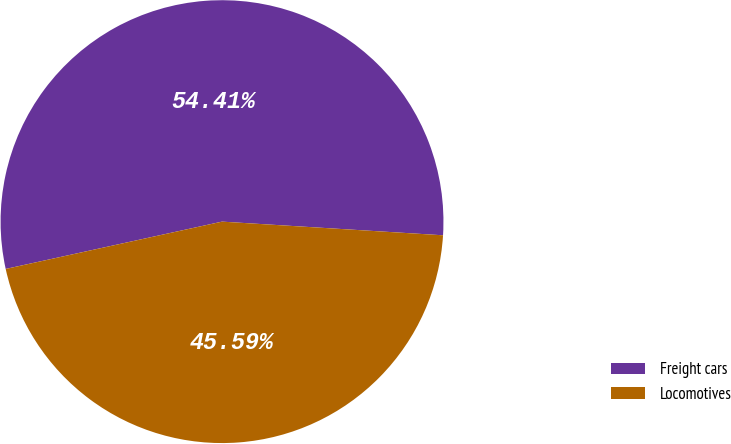Convert chart to OTSL. <chart><loc_0><loc_0><loc_500><loc_500><pie_chart><fcel>Freight cars<fcel>Locomotives<nl><fcel>54.41%<fcel>45.59%<nl></chart> 